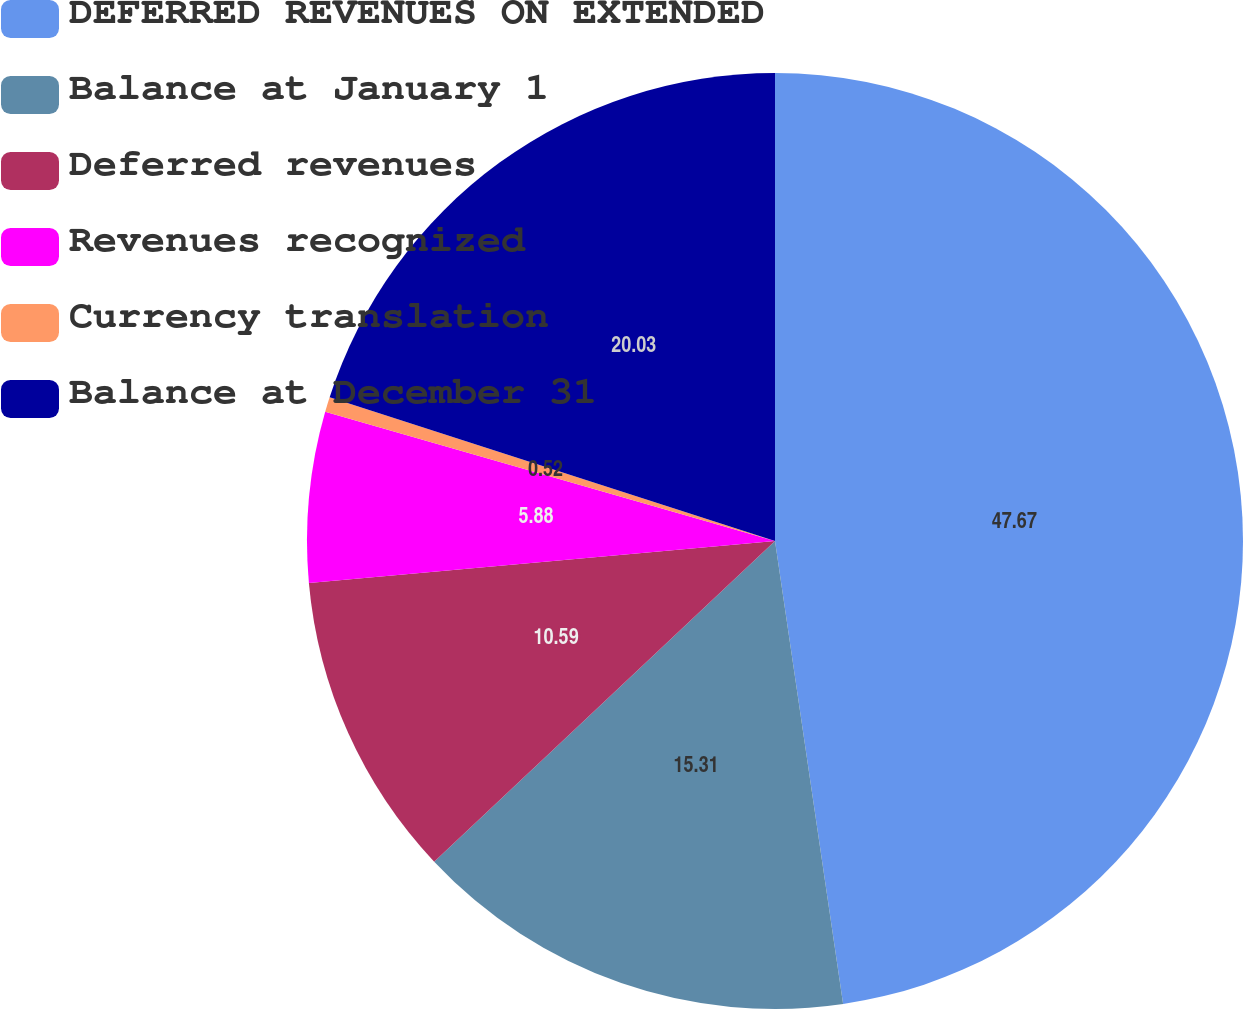Convert chart to OTSL. <chart><loc_0><loc_0><loc_500><loc_500><pie_chart><fcel>DEFERRED REVENUES ON EXTENDED<fcel>Balance at January 1<fcel>Deferred revenues<fcel>Revenues recognized<fcel>Currency translation<fcel>Balance at December 31<nl><fcel>47.68%<fcel>15.31%<fcel>10.59%<fcel>5.88%<fcel>0.52%<fcel>20.03%<nl></chart> 